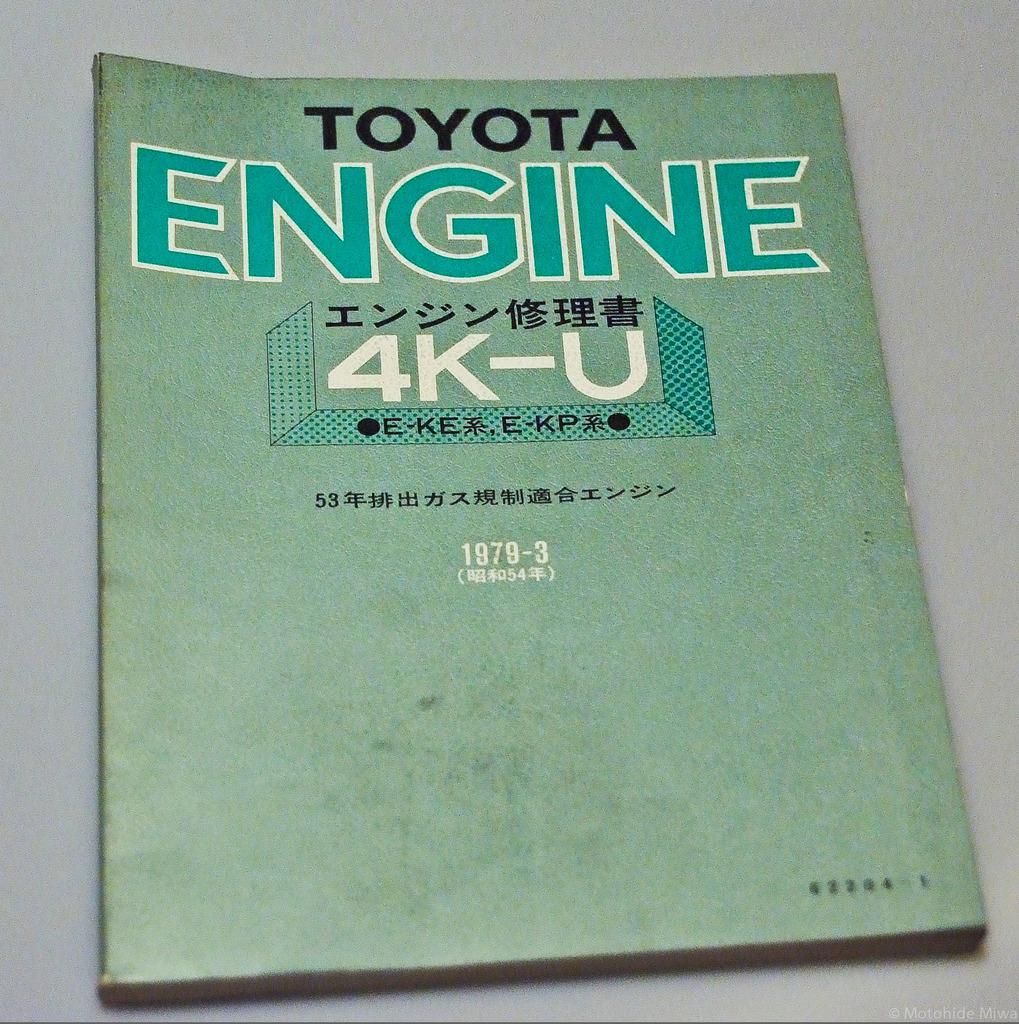What car maker is this for?
Provide a succinct answer. Toyota. 